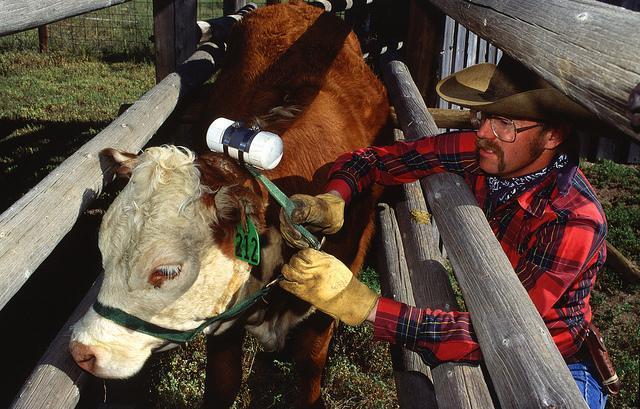Is the statement "The cow is facing the person." accurate regarding the image?
Answer yes or no. No. Does the image validate the caption "The cow is facing away from the person."?
Answer yes or no. Yes. Verify the accuracy of this image caption: "The person is ahead of the cow.".
Answer yes or no. No. 